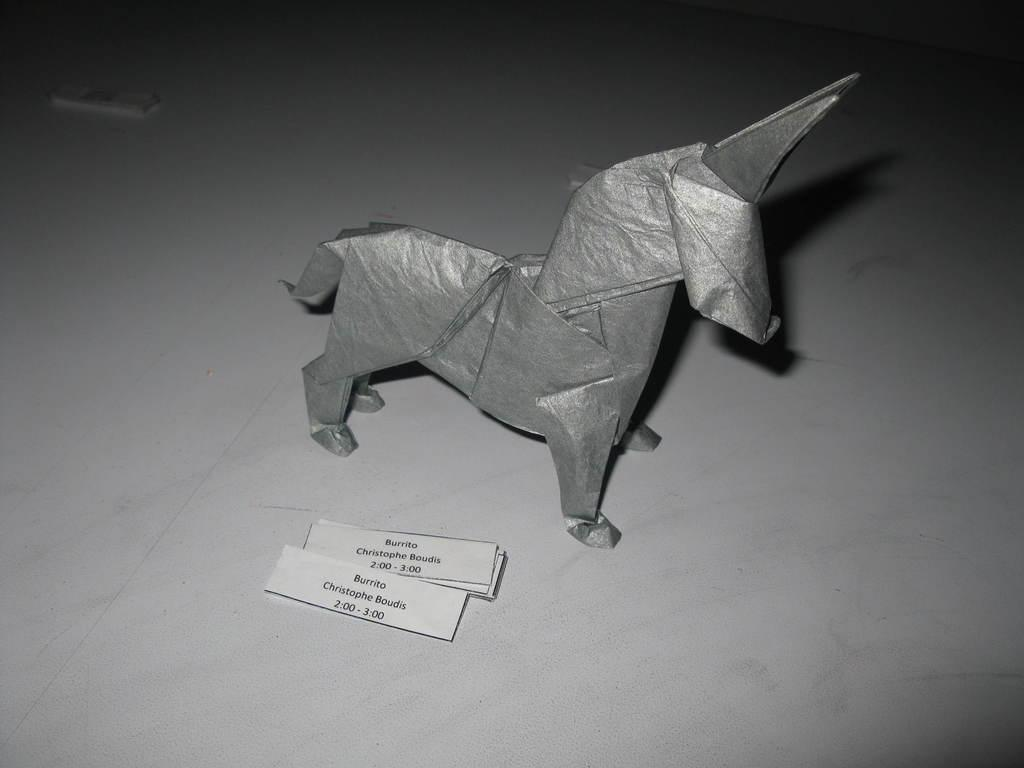What type of animal is depicted in the image? There is a paper horse in the image. Are there any additional details or features at the bottom of the image? Yes, there are labels at the bottom of the image. What type of fruit is being used to create the paper horse in the image? There is no fruit, such as a pear, present in the image, and the horse is made of paper, not fruit. 